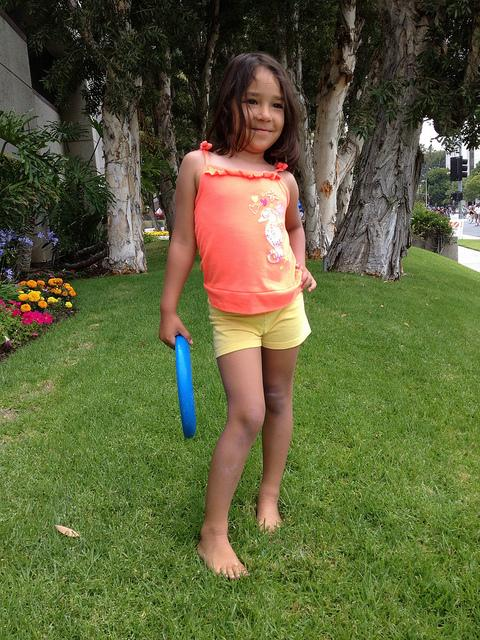The girl is positioning her body in the way a model does by doing what? Please explain your reasoning. posing. She's posing. 